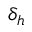Convert formula to latex. <formula><loc_0><loc_0><loc_500><loc_500>\delta _ { h }</formula> 